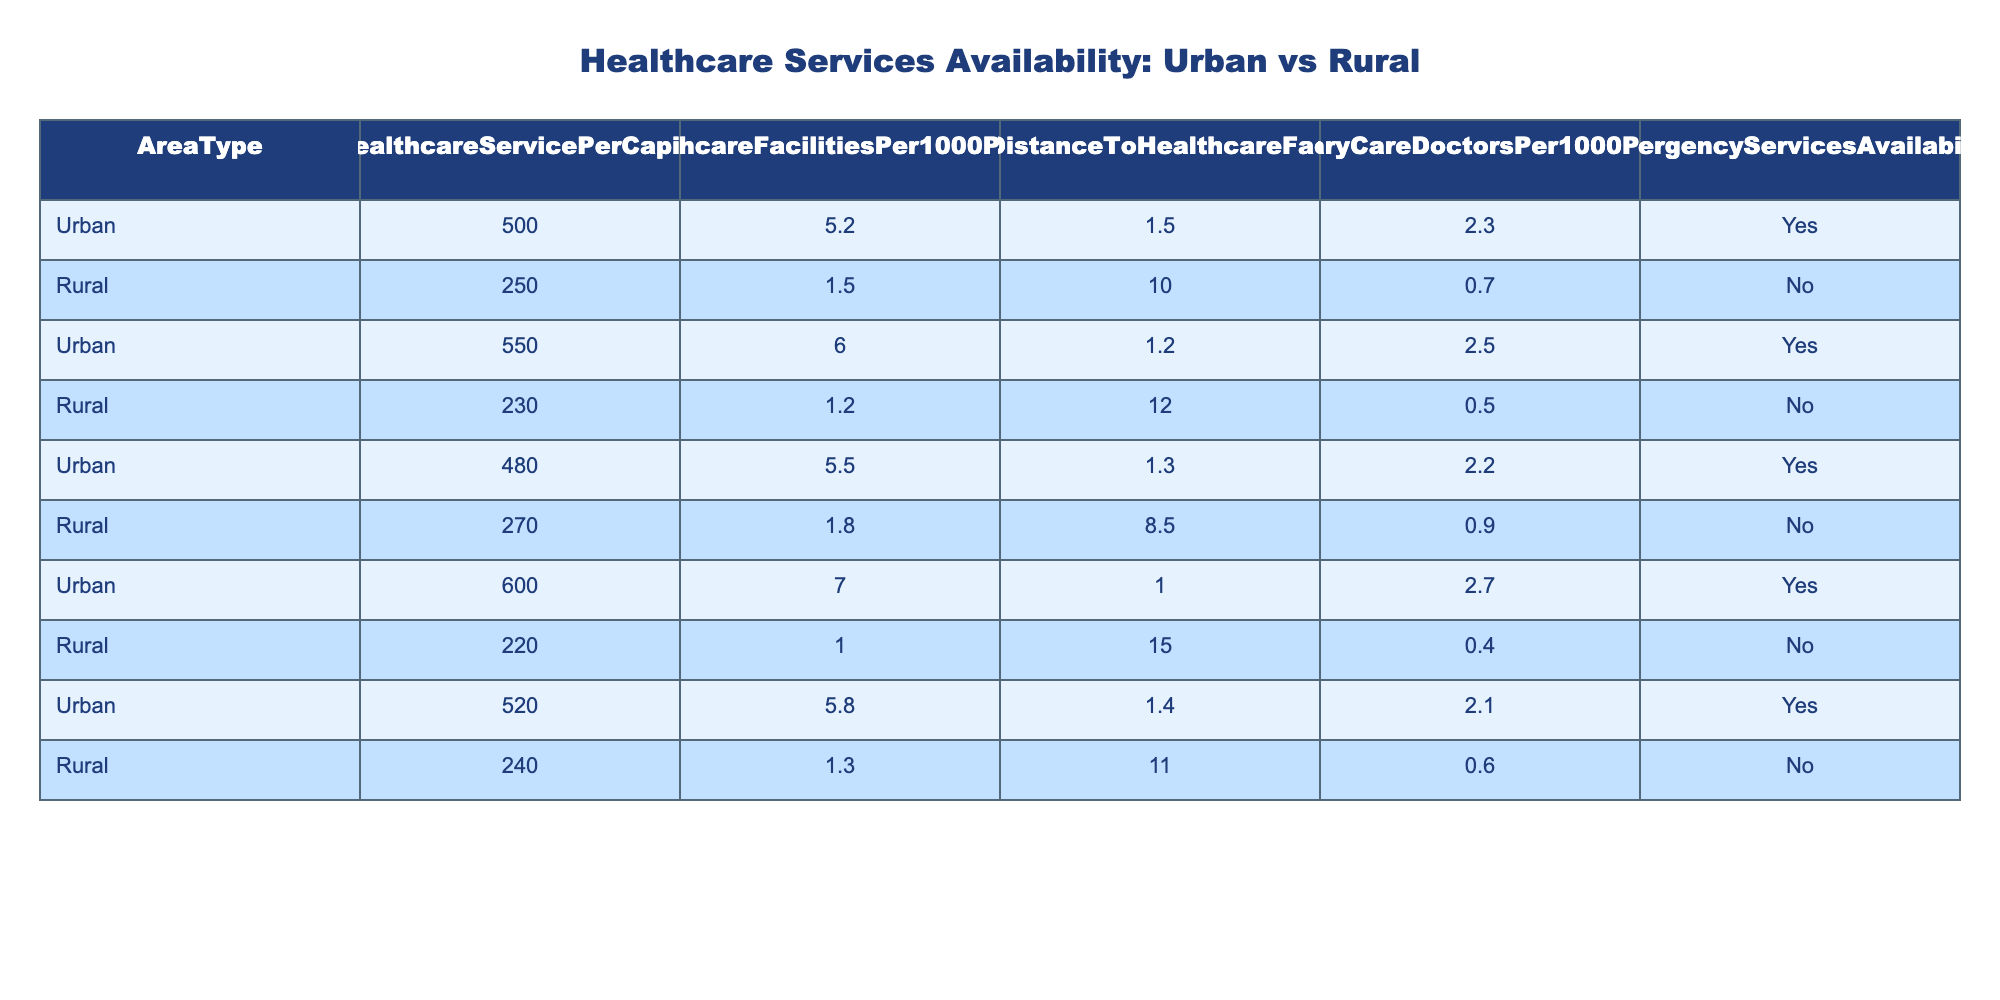What is the healthcare service availability per capita in rural areas? From the table, the healthcare service per capita for rural areas is listed as 250.
Answer: 250 What is the average distance to a healthcare facility in urban areas? The table shows three urban entries with distances of 1.5, 1.2, and 1.3 km. The average is (1.5 + 1.2 + 1.3) / 3 = 1.33 km.
Answer: 1.33 km How many primary care doctors are available per 1000 people in rural areas? The table shows data for rural areas having values of 0.7, 0.5, 0.9, 0.4, and 0.6 primary care doctors per 1000 people. We can take the average as (0.7 + 0.5 + 0.9 + 0.4 + 0.6) / 5 = 0.62.
Answer: 0.62 Is emergency services availability present in rural areas? The table indicates that for all rural entries, emergency services availability is marked as 'No'.
Answer: No What is the difference in healthcare facilities per 1000 people between urban and rural areas? Urban areas have 5.2, 6.0, 5.5, 7.0, 5.8 healthcare facilities per 1000 people. The average for urban areas is (5.2 + 6.0 + 5.5 + 7.0 + 5.8) / 5 = 5.70. For rural areas the average is (1.5 + 1.2 + 1.8 + 1.0 + 1.3) / 5 = 1.36. Thus, the difference is 5.7 - 1.36 = 4.34 facilities per 1000 people.
Answer: 4.34 facilities Which area type has a higher value for healthcare services per capita? Comparing the urban and rural values, urban healthcare services per capita are 500, 550, 480, 600, 520 (average = 520) compared to rural’s average of 250. Urban areas are higher.
Answer: Urban areas What is the total number of healthcare service per capita for urban areas in this dataset? Summing the values 500 + 550 + 480 + 600 + 520 gives us a total of 2650.
Answer: 2650 Are there any urban areas with emergency services availability? The table indicates that all urban entries have emergency services availability marked as 'Yes'.
Answer: Yes What is the ratio of primary care doctors per 1000 people in urban versus rural areas? The average number of primary care doctors for urban areas is (2.3 + 2.5 + 2.2 + 2.7 + 2.1) / 5 = 2.36. The average for rural is 0.62. The ratio of urban to rural is 2.36 / 0.62 = 3.81.
Answer: 3.81 What is the highest average distance to a healthcare facility reported in the rural areas? Among rural areas, the distances provided are 10.0, 12.0, 8.5, 15.0, and 11.0 km making 15.0 the highest recorded distance.
Answer: 15.0 km If we combine healthcare services per capita from urban and rural areas, what is the overall total? The total for urban is 2650 and for rural is 1250 (250 + 230 + 270 + 220 + 240), summing them gives 2650 + 1250 = 3900.
Answer: 3900 